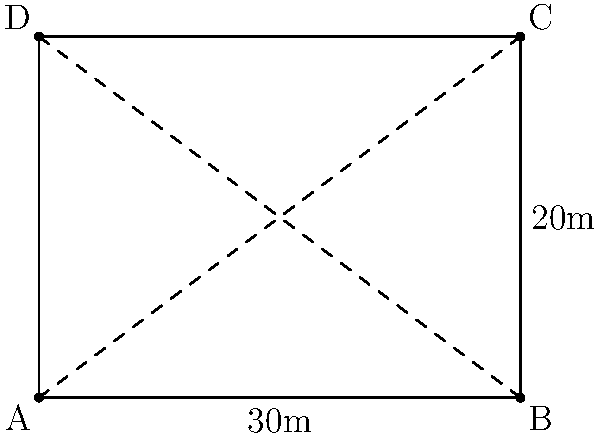You have a rectangular field with dimensions 30m by 20m. You need to install an irrigation system that connects opposite corners of the field. Which diagonal path requires less piping: A to C or B to D? How much shorter is it? To solve this problem, we'll use vector operations:

1) First, let's define vectors for both diagonals:
   $\vec{AC} = (30, 20)$
   $\vec{BD} = (30, -20)$

2) The length of each diagonal can be calculated using the magnitude of these vectors:
   $|\vec{AC}| = \sqrt{30^2 + 20^2} = \sqrt{1300}$
   $|\vec{BD}| = \sqrt{30^2 + (-20)^2} = \sqrt{1300}$

3) We can see that both diagonals have the same length: $\sqrt{1300}$ meters.

4) To convert this to a decimal:
   $\sqrt{1300} \approx 36.06$ meters

5) Since both diagonals have the same length, neither path is shorter.
Answer: Neither; both diagonals are equal at approximately 36.06 meters. 